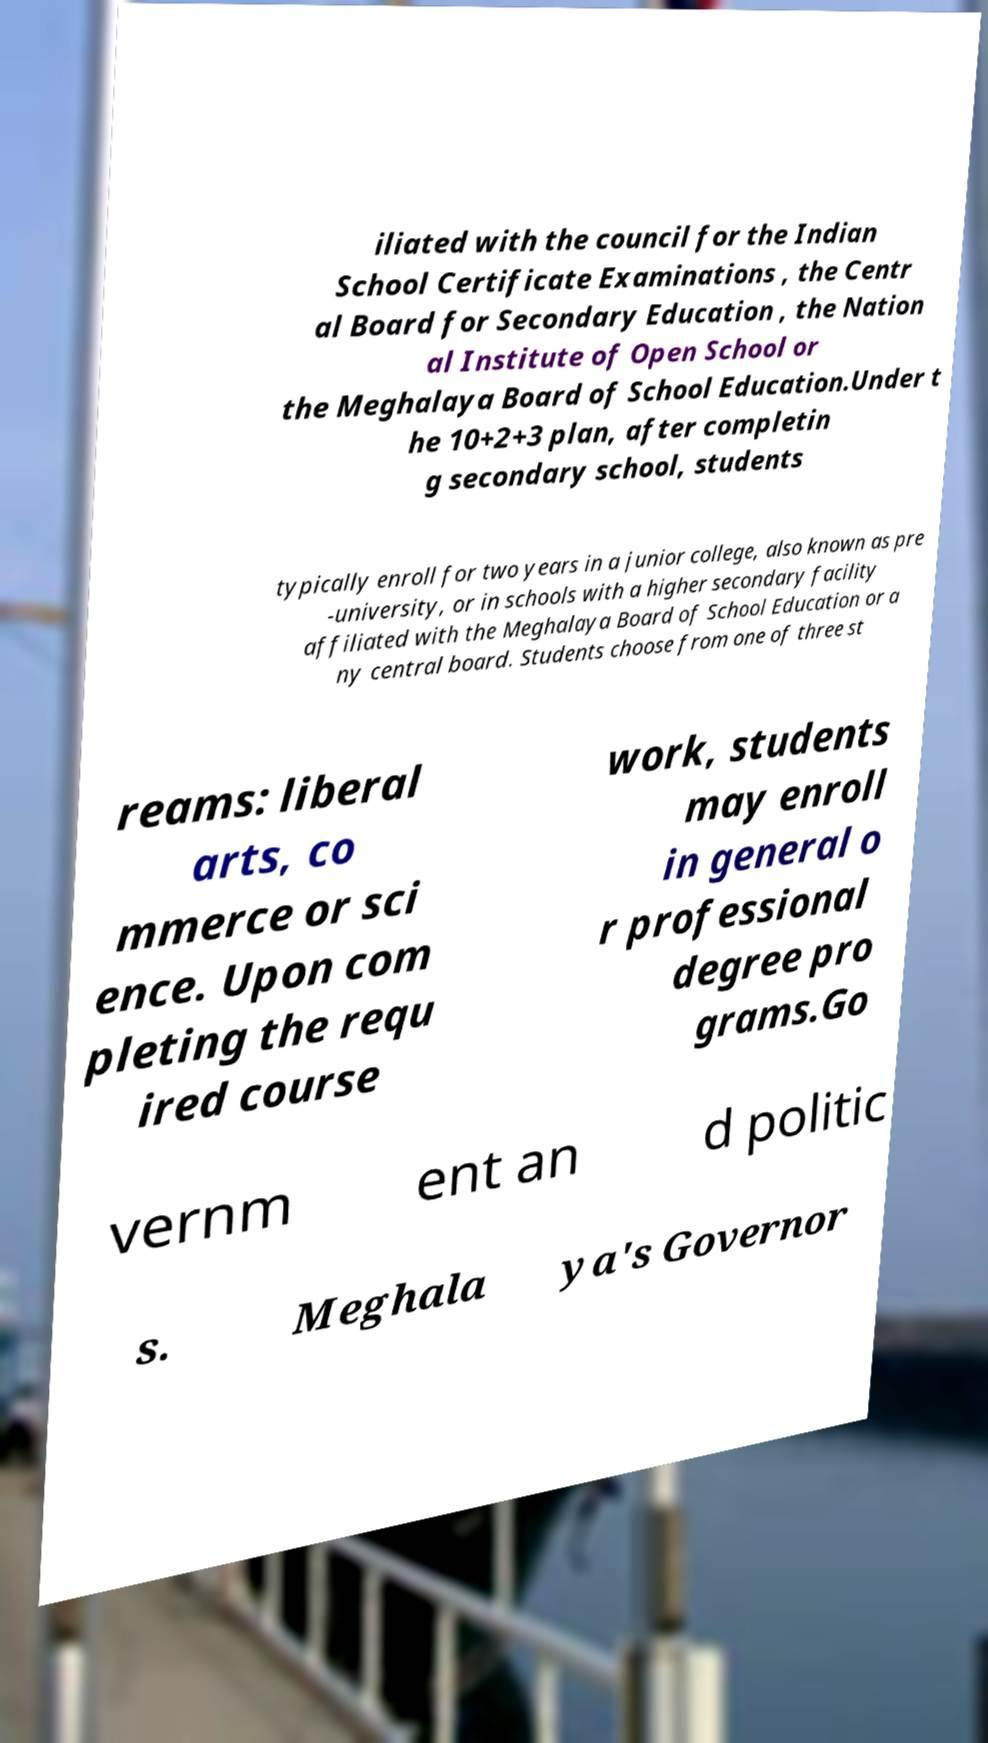Could you extract and type out the text from this image? iliated with the council for the Indian School Certificate Examinations , the Centr al Board for Secondary Education , the Nation al Institute of Open School or the Meghalaya Board of School Education.Under t he 10+2+3 plan, after completin g secondary school, students typically enroll for two years in a junior college, also known as pre -university, or in schools with a higher secondary facility affiliated with the Meghalaya Board of School Education or a ny central board. Students choose from one of three st reams: liberal arts, co mmerce or sci ence. Upon com pleting the requ ired course work, students may enroll in general o r professional degree pro grams.Go vernm ent an d politic s. Meghala ya's Governor 